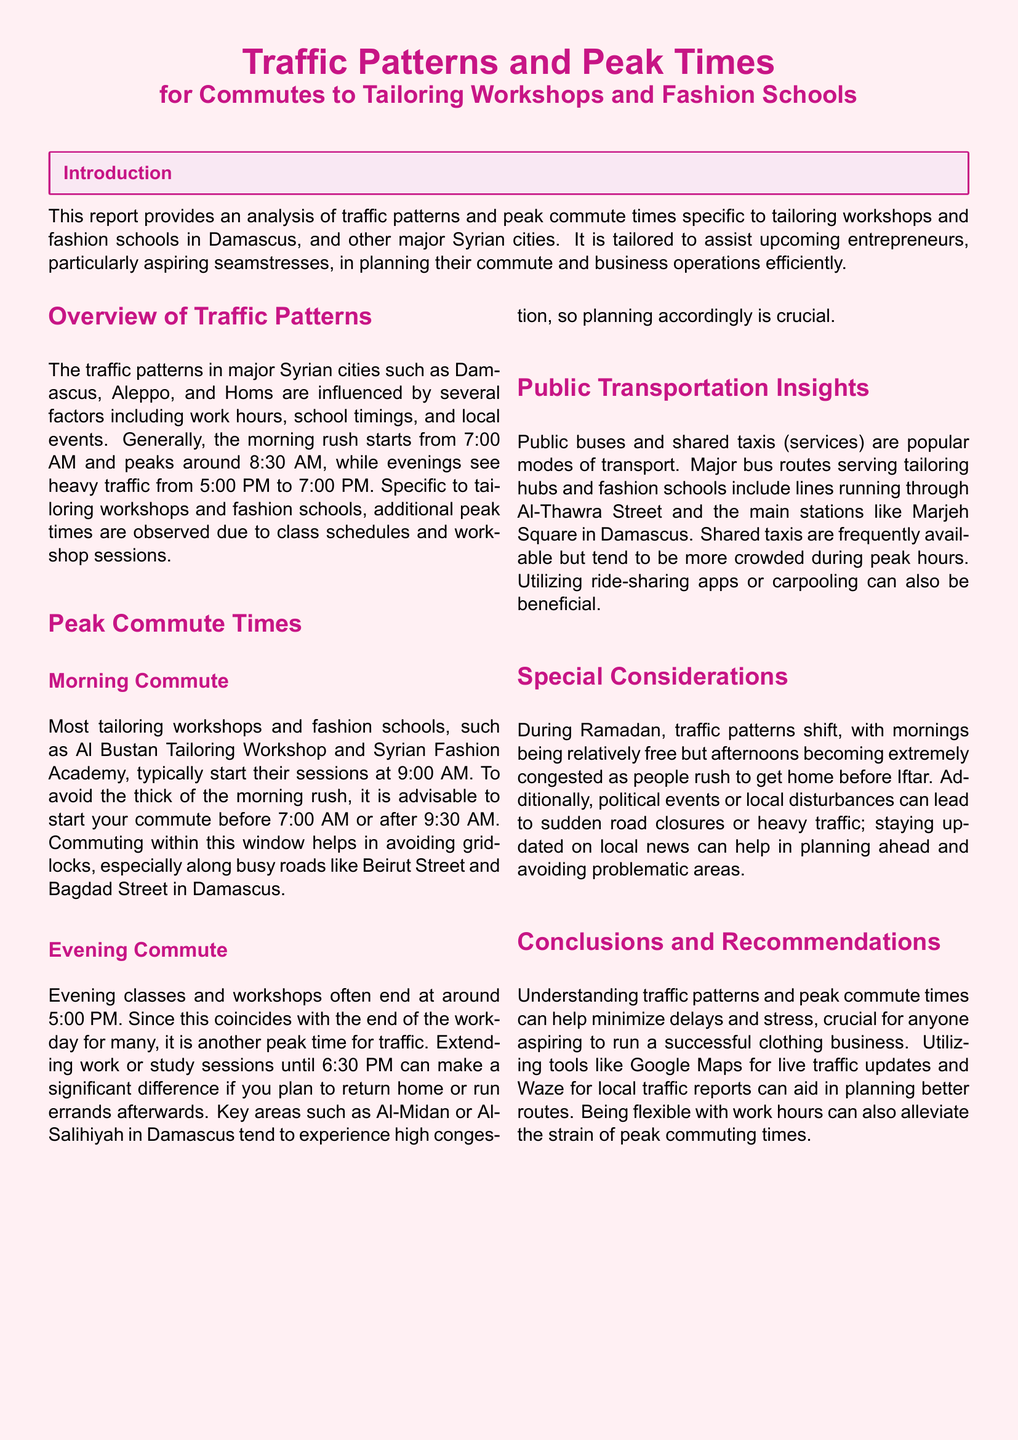what are the peak morning commute times? The report specifies that the morning rush starts at 7:00 AM and peaks around 8:30 AM.
Answer: 8:30 AM what is advised for the morning commute? To avoid traffic, it's advisable to start your commute before 7:00 AM or after 9:30 AM.
Answer: before 7:00 AM or after 9:30 AM which streets in Damascus experience traffic congestion? Busy roads mentioned are Beirut Street and Bagdad Street experiencing gridlocks.
Answer: Beirut Street and Bagdad Street what is the typical end time for evening classes? Evening workshops often end at around 5:00 PM.
Answer: 5:00 PM which public transport modes are popular? Public buses and shared taxis are noted as popular transport modes.
Answer: Public buses and shared taxis how can one avoid peak traffic? The report suggests utilizing tools like Google Maps and Waze for live traffic updates.
Answer: Google Maps and Waze what changes during Ramadan regarding traffic patterns? Mornings are relatively free, while afternoons become extremely congested as people rush home.
Answer: mornings relatively free, afternoons congested where are tailoring hubs and fashion schools serviced by buses? Major bus routes serve tailoring hubs along Al-Thawra Street and Marjeh Square.
Answer: Al-Thawra Street and Marjeh Square what can help minimize delays and stress for commuters? Understanding traffic patterns and being flexible with work hours can help in minimizing delays.
Answer: understanding traffic patterns and flexibility 